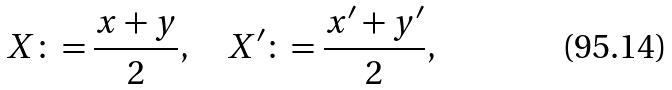<formula> <loc_0><loc_0><loc_500><loc_500>X \colon = \frac { x + y } { 2 } , \quad X ^ { \prime } \colon = \frac { x ^ { \prime } + y ^ { \prime } } { 2 } ,</formula> 